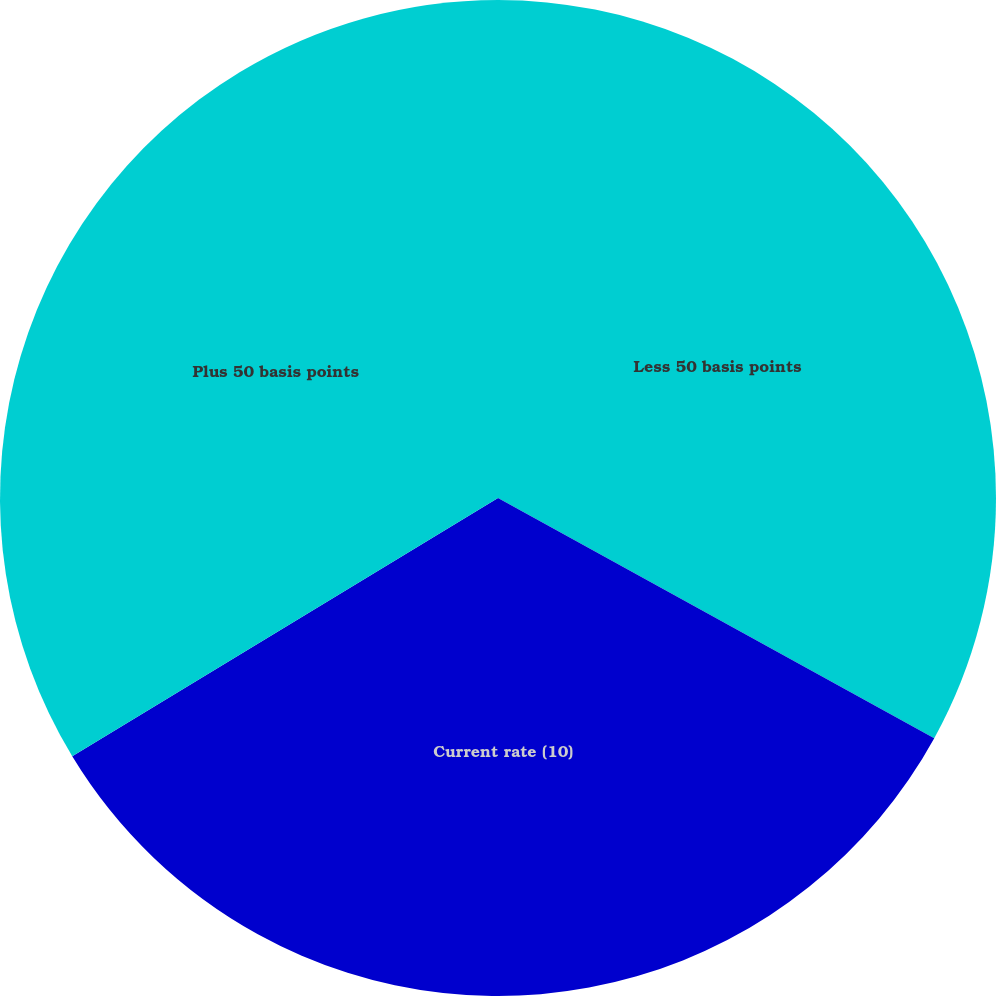<chart> <loc_0><loc_0><loc_500><loc_500><pie_chart><fcel>Less 50 basis points<fcel>Current rate (10)<fcel>Plus 50 basis points<nl><fcel>33.01%<fcel>33.31%<fcel>33.68%<nl></chart> 